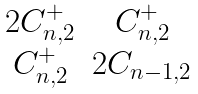<formula> <loc_0><loc_0><loc_500><loc_500>\begin{matrix} 2 C _ { n , 2 } ^ { + } & C _ { n , 2 } ^ { + } \\ C _ { n , 2 } ^ { + } & 2 C _ { n - 1 , 2 } \end{matrix}</formula> 